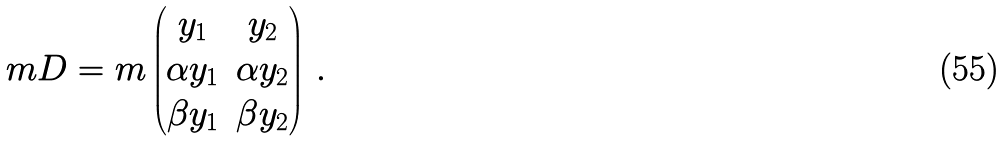<formula> <loc_0><loc_0><loc_500><loc_500>\ m D = m \begin{pmatrix} y _ { 1 } & y _ { 2 } \\ \alpha y _ { 1 } & \alpha y _ { 2 } \\ \beta y _ { 1 } & \beta y _ { 2 } \end{pmatrix} \, .</formula> 